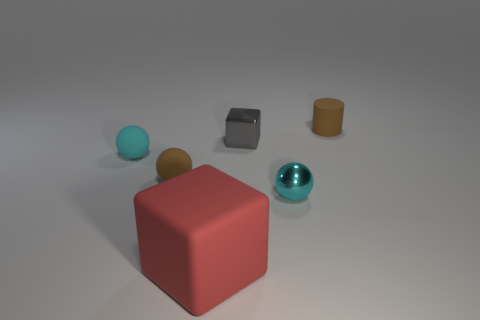Add 2 shiny cubes. How many objects exist? 8 Subtract all blocks. How many objects are left? 4 Subtract 0 cyan cylinders. How many objects are left? 6 Subtract all tiny shiny objects. Subtract all tiny brown things. How many objects are left? 2 Add 4 tiny shiny cubes. How many tiny shiny cubes are left? 5 Add 4 red objects. How many red objects exist? 5 